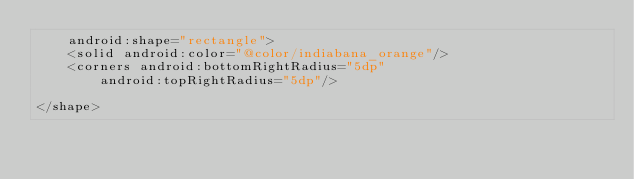Convert code to text. <code><loc_0><loc_0><loc_500><loc_500><_XML_>    android:shape="rectangle">
    <solid android:color="@color/indiabana_orange"/>
    <corners android:bottomRightRadius="5dp"
        android:topRightRadius="5dp"/>

</shape></code> 